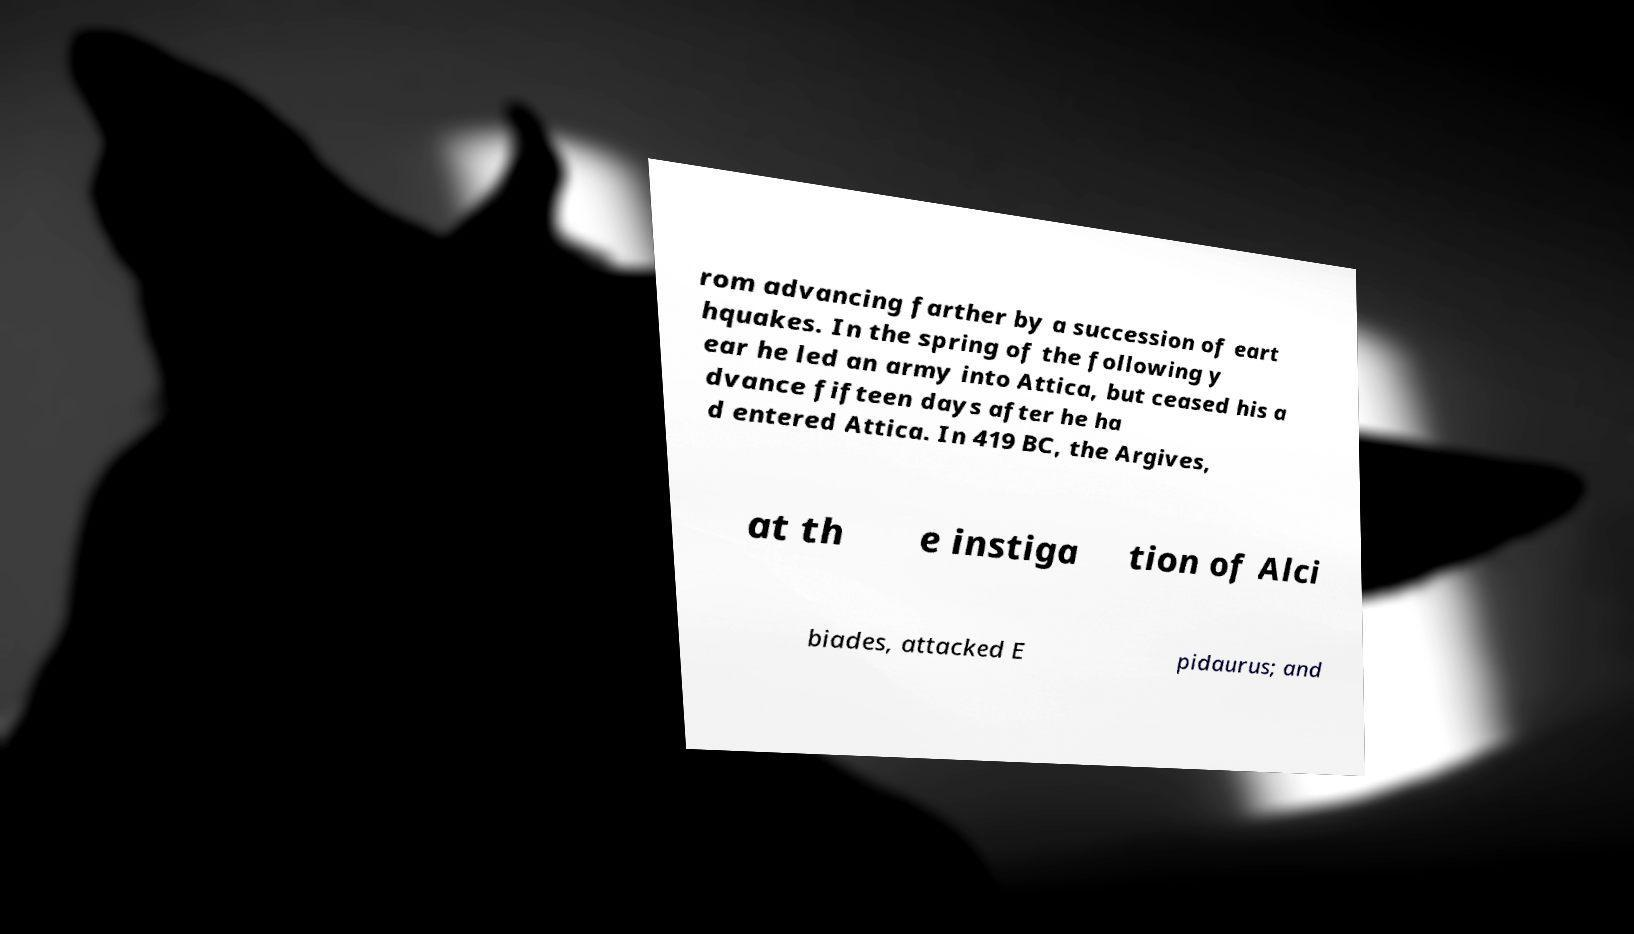Please read and relay the text visible in this image. What does it say? rom advancing farther by a succession of eart hquakes. In the spring of the following y ear he led an army into Attica, but ceased his a dvance fifteen days after he ha d entered Attica. In 419 BC, the Argives, at th e instiga tion of Alci biades, attacked E pidaurus; and 